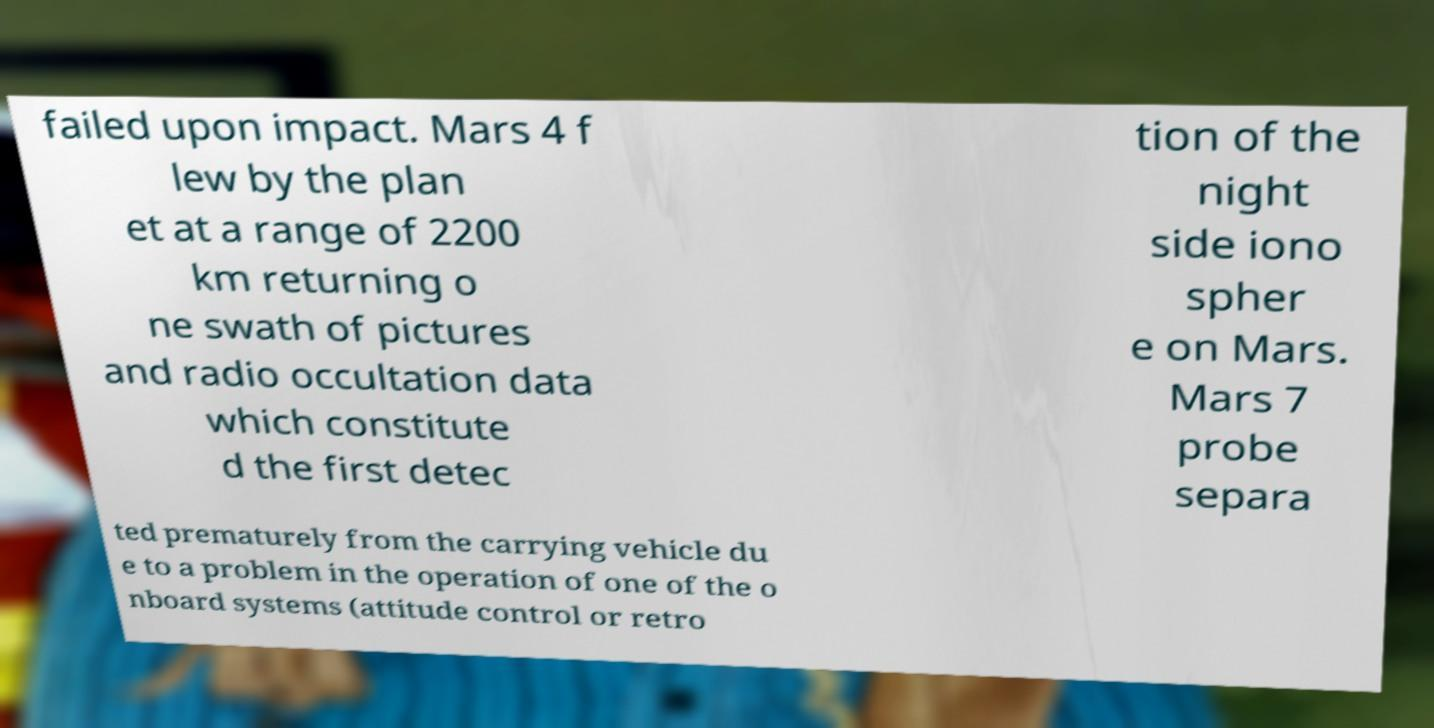I need the written content from this picture converted into text. Can you do that? failed upon impact. Mars 4 f lew by the plan et at a range of 2200 km returning o ne swath of pictures and radio occultation data which constitute d the first detec tion of the night side iono spher e on Mars. Mars 7 probe separa ted prematurely from the carrying vehicle du e to a problem in the operation of one of the o nboard systems (attitude control or retro 